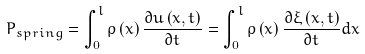<formula> <loc_0><loc_0><loc_500><loc_500>P _ { s p r i n g } = \int _ { 0 } ^ { l } \rho \left ( x \right ) \frac { \partial u \left ( x , t \right ) } { \partial t } = \int _ { 0 } ^ { l } \rho \left ( x \right ) \frac { \partial \xi \left ( x , t \right ) } { \partial t } d x</formula> 